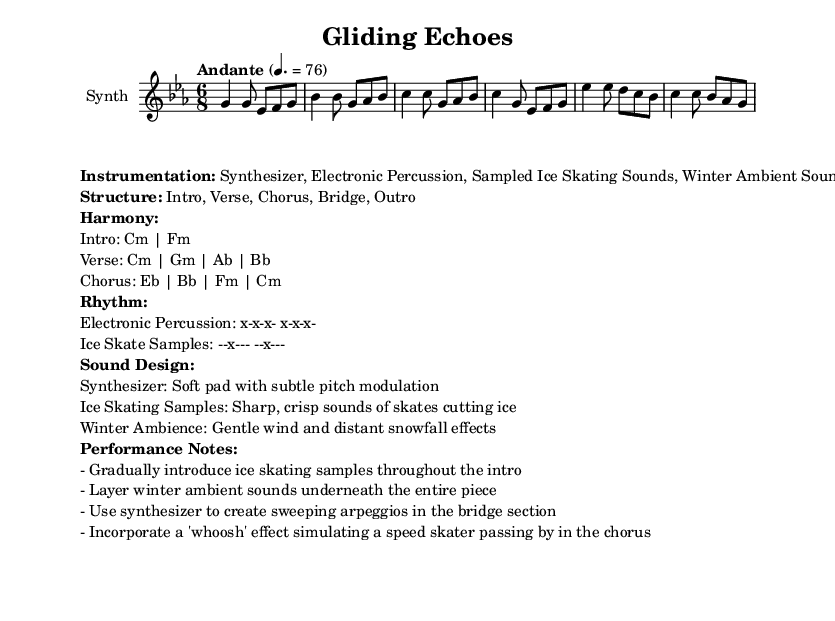What is the key signature of this music? The key signature is C minor, indicated by the presence of three flats (B-flat, E-flat, A-flat).
Answer: C minor What is the time signature of this piece? The time signature is 6/8, which is shown at the beginning of the score, indicating there are six eighth notes in each measure.
Answer: 6/8 What is the tempo marking of this piece? The tempo marking "Andante" suggests a moderately slow pace, which is further quantified with a metronome marking of 76 beats per minute for quarter notes.
Answer: Andante, 76 What is the structure of this composition? The structure is outlined in the markup as "Intro, Verse, Chorus, Bridge, Outro", indicating the organized sections of the piece.
Answer: Intro, Verse, Chorus, Bridge, Outro Which instrument is primarily used in the score? The instrument is specified as "Synth", which references the synthesizer part in the score that carries the main melodic elements.
Answer: Synth What is the role of ice skating samples in the performance? The ice skating samples are introduced gradually throughout the intro, with a focus on creating sharp, crisp sounds that imitate skates on ice, enhancing the winter theme.
Answer: Gradual introduction How does the piece incorporate winter ambiance? Winter ambiance is layered continuously underneath the entire piece, providing a background of gentle wind and distant snowfall, creating a serene winter atmosphere throughout the performance.
Answer: Gentle wind, distant snowfall 